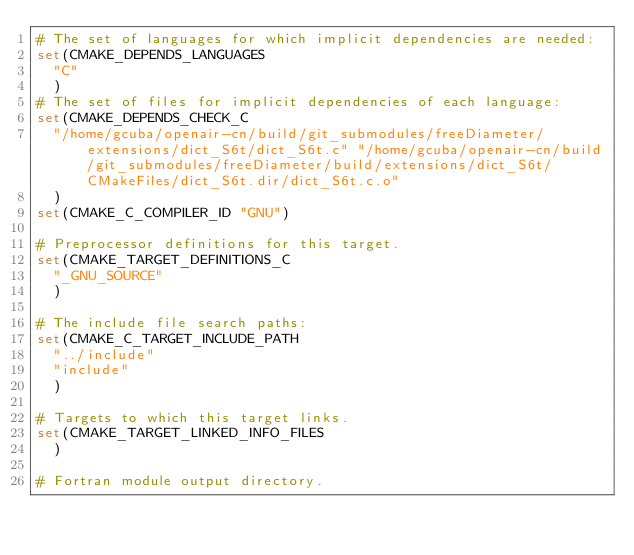<code> <loc_0><loc_0><loc_500><loc_500><_CMake_># The set of languages for which implicit dependencies are needed:
set(CMAKE_DEPENDS_LANGUAGES
  "C"
  )
# The set of files for implicit dependencies of each language:
set(CMAKE_DEPENDS_CHECK_C
  "/home/gcuba/openair-cn/build/git_submodules/freeDiameter/extensions/dict_S6t/dict_S6t.c" "/home/gcuba/openair-cn/build/git_submodules/freeDiameter/build/extensions/dict_S6t/CMakeFiles/dict_S6t.dir/dict_S6t.c.o"
  )
set(CMAKE_C_COMPILER_ID "GNU")

# Preprocessor definitions for this target.
set(CMAKE_TARGET_DEFINITIONS_C
  "_GNU_SOURCE"
  )

# The include file search paths:
set(CMAKE_C_TARGET_INCLUDE_PATH
  "../include"
  "include"
  )

# Targets to which this target links.
set(CMAKE_TARGET_LINKED_INFO_FILES
  )

# Fortran module output directory.</code> 